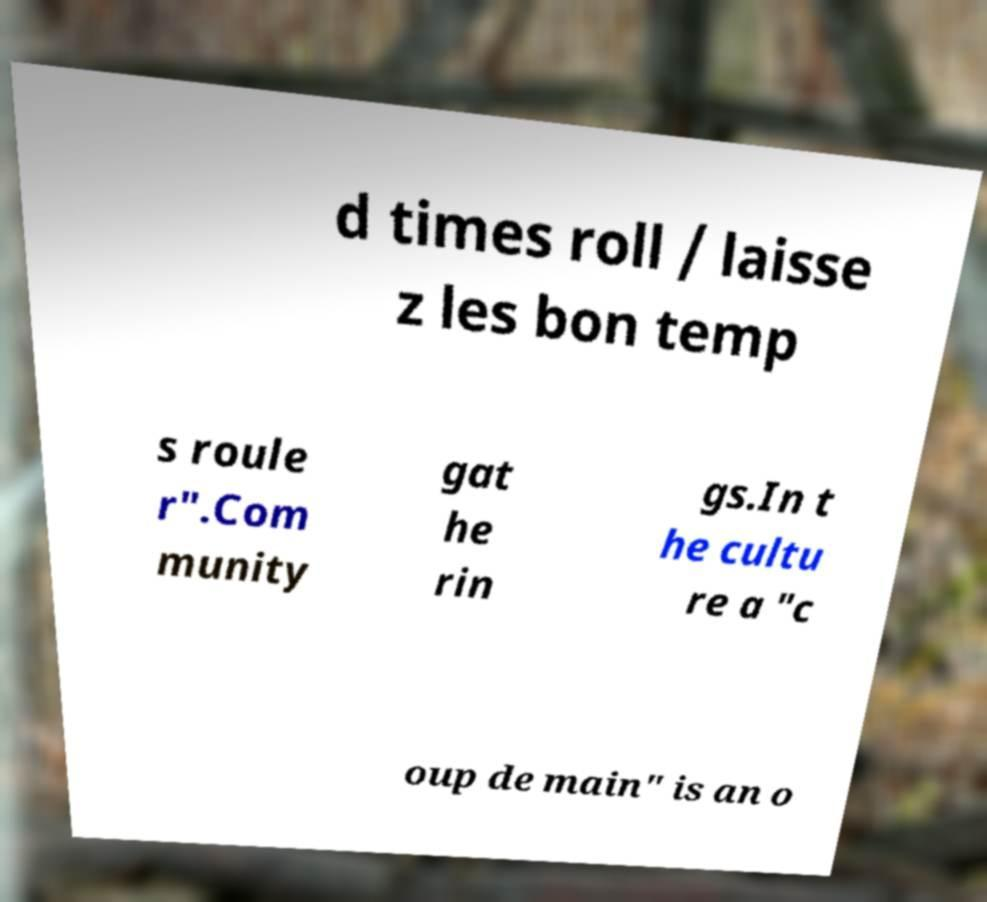Could you extract and type out the text from this image? d times roll / laisse z les bon temp s roule r".Com munity gat he rin gs.In t he cultu re a "c oup de main" is an o 